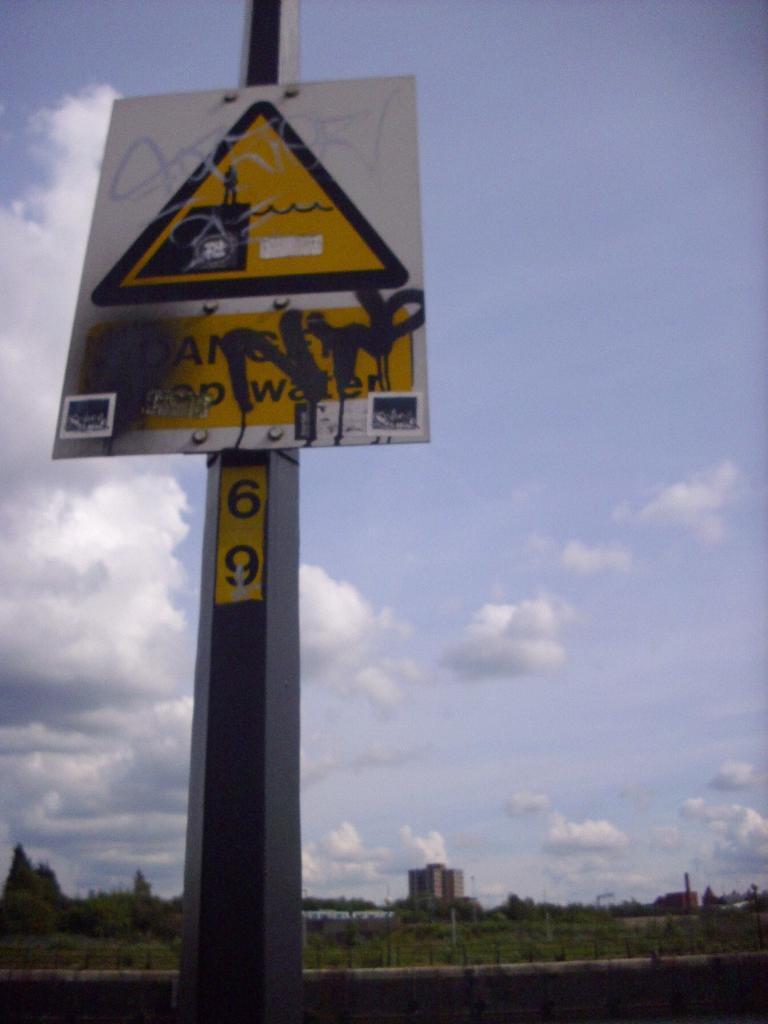How would you summarize this image in a sentence or two? In the foreground of this image, there is a sign board to a pole, In the background, there are trees, few buildings, the sky and the cloud. 